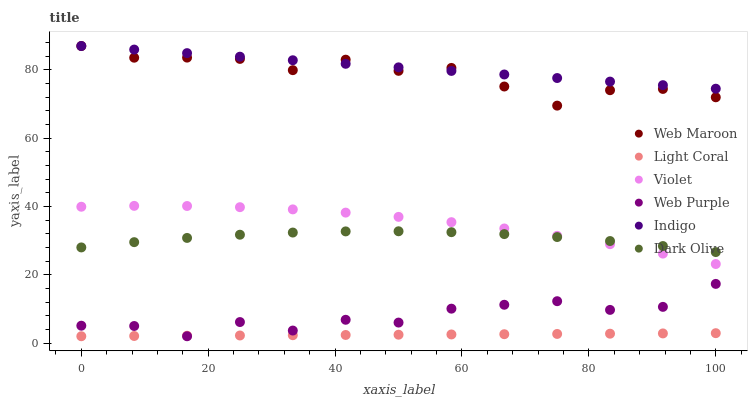Does Light Coral have the minimum area under the curve?
Answer yes or no. Yes. Does Indigo have the maximum area under the curve?
Answer yes or no. Yes. Does Dark Olive have the minimum area under the curve?
Answer yes or no. No. Does Dark Olive have the maximum area under the curve?
Answer yes or no. No. Is Light Coral the smoothest?
Answer yes or no. Yes. Is Web Purple the roughest?
Answer yes or no. Yes. Is Dark Olive the smoothest?
Answer yes or no. No. Is Dark Olive the roughest?
Answer yes or no. No. Does Light Coral have the lowest value?
Answer yes or no. Yes. Does Dark Olive have the lowest value?
Answer yes or no. No. Does Web Maroon have the highest value?
Answer yes or no. Yes. Does Dark Olive have the highest value?
Answer yes or no. No. Is Dark Olive less than Indigo?
Answer yes or no. Yes. Is Indigo greater than Dark Olive?
Answer yes or no. Yes. Does Web Maroon intersect Indigo?
Answer yes or no. Yes. Is Web Maroon less than Indigo?
Answer yes or no. No. Is Web Maroon greater than Indigo?
Answer yes or no. No. Does Dark Olive intersect Indigo?
Answer yes or no. No. 